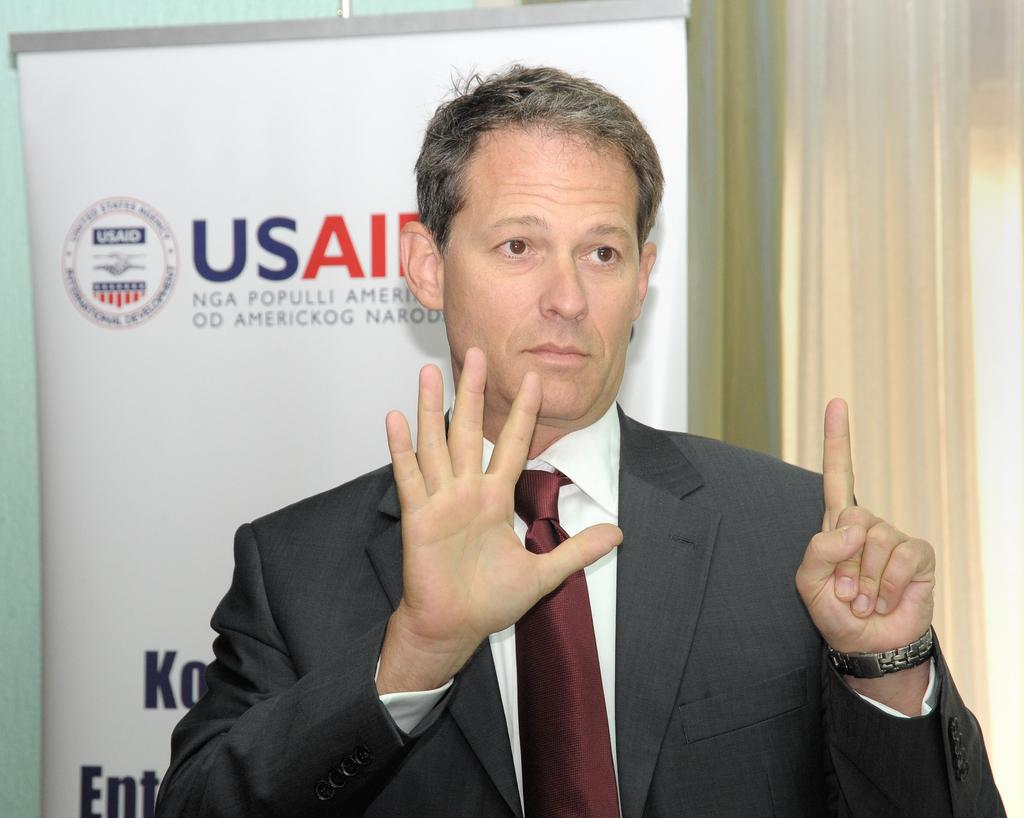What is the main subject of the picture? The main subject of the picture is a man. Can you describe the man's clothing? The man is wearing a blazer. Does the man have any unusual physical features? Yes, the man has six fingers. What else can be seen in the picture besides the man? There is a banner and a curtain behind the banner in the picture. What type of verse is being recited by the man in the picture? There is no indication in the image that the man is reciting a verse, so it cannot be determined from the picture. 